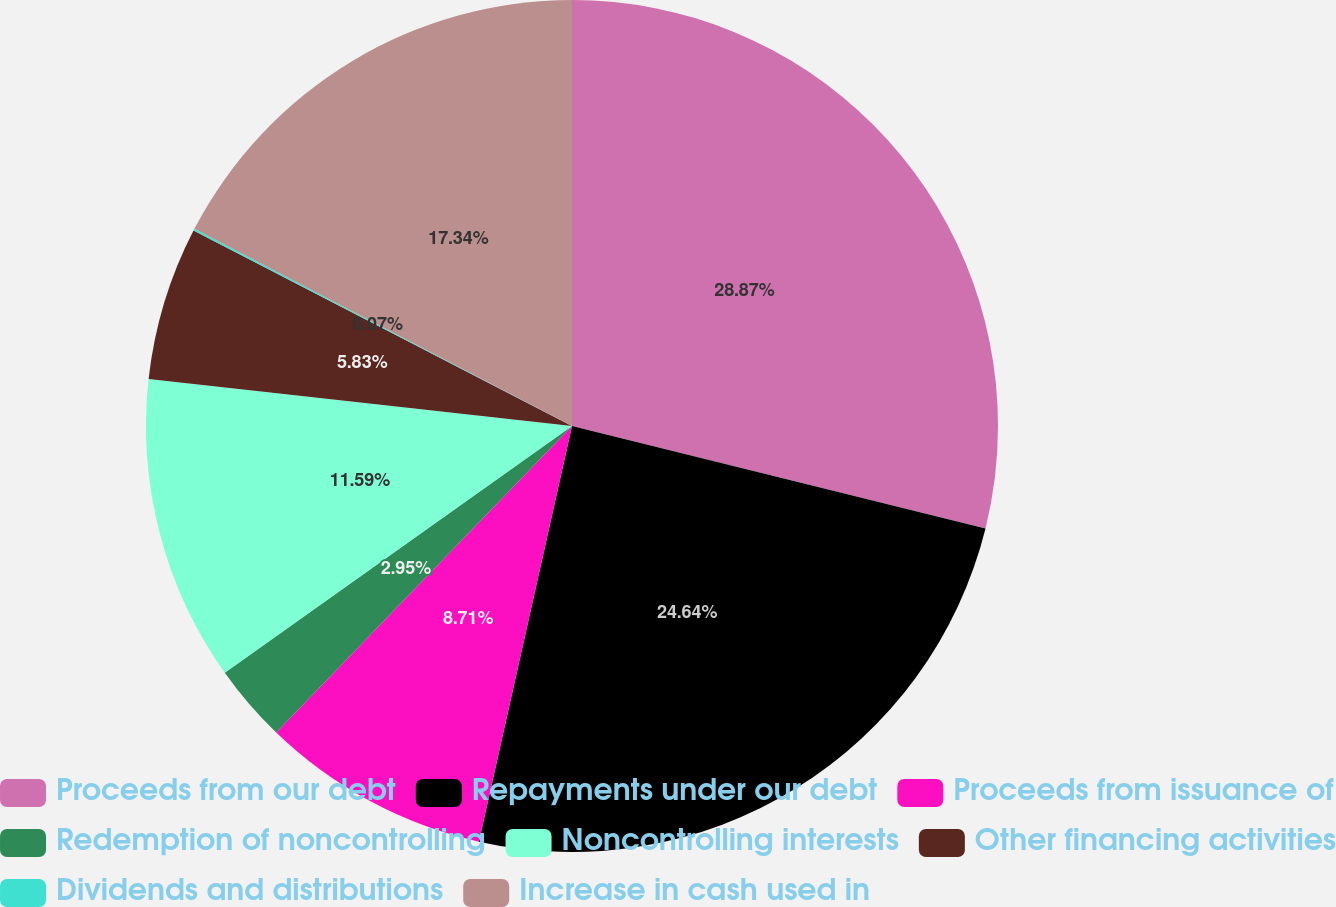Convert chart to OTSL. <chart><loc_0><loc_0><loc_500><loc_500><pie_chart><fcel>Proceeds from our debt<fcel>Repayments under our debt<fcel>Proceeds from issuance of<fcel>Redemption of noncontrolling<fcel>Noncontrolling interests<fcel>Other financing activities<fcel>Dividends and distributions<fcel>Increase in cash used in<nl><fcel>28.86%<fcel>24.64%<fcel>8.71%<fcel>2.95%<fcel>11.59%<fcel>5.83%<fcel>0.07%<fcel>17.34%<nl></chart> 